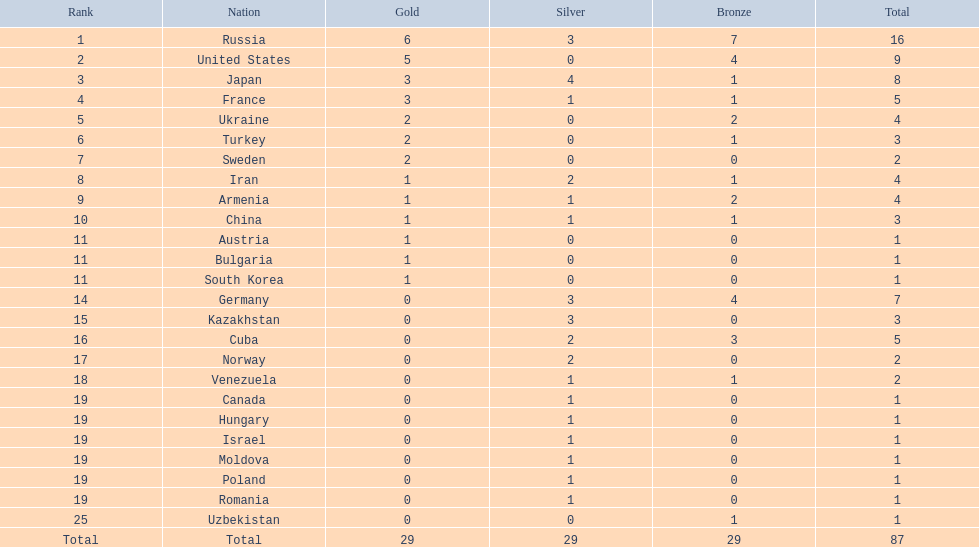How many gold medals did the united states achieve? 5. Who secured more than 5 gold medals? Russia. 